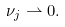<formula> <loc_0><loc_0><loc_500><loc_500>\nu _ { j } \rightharpoonup 0 .</formula> 